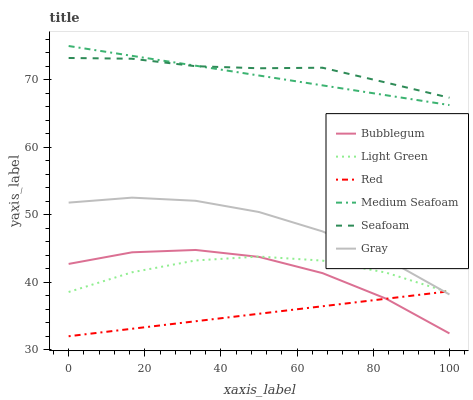Does Red have the minimum area under the curve?
Answer yes or no. Yes. Does Seafoam have the maximum area under the curve?
Answer yes or no. Yes. Does Bubblegum have the minimum area under the curve?
Answer yes or no. No. Does Bubblegum have the maximum area under the curve?
Answer yes or no. No. Is Red the smoothest?
Answer yes or no. Yes. Is Bubblegum the roughest?
Answer yes or no. Yes. Is Seafoam the smoothest?
Answer yes or no. No. Is Seafoam the roughest?
Answer yes or no. No. Does Red have the lowest value?
Answer yes or no. Yes. Does Bubblegum have the lowest value?
Answer yes or no. No. Does Medium Seafoam have the highest value?
Answer yes or no. Yes. Does Seafoam have the highest value?
Answer yes or no. No. Is Light Green less than Medium Seafoam?
Answer yes or no. Yes. Is Medium Seafoam greater than Gray?
Answer yes or no. Yes. Does Seafoam intersect Medium Seafoam?
Answer yes or no. Yes. Is Seafoam less than Medium Seafoam?
Answer yes or no. No. Is Seafoam greater than Medium Seafoam?
Answer yes or no. No. Does Light Green intersect Medium Seafoam?
Answer yes or no. No. 